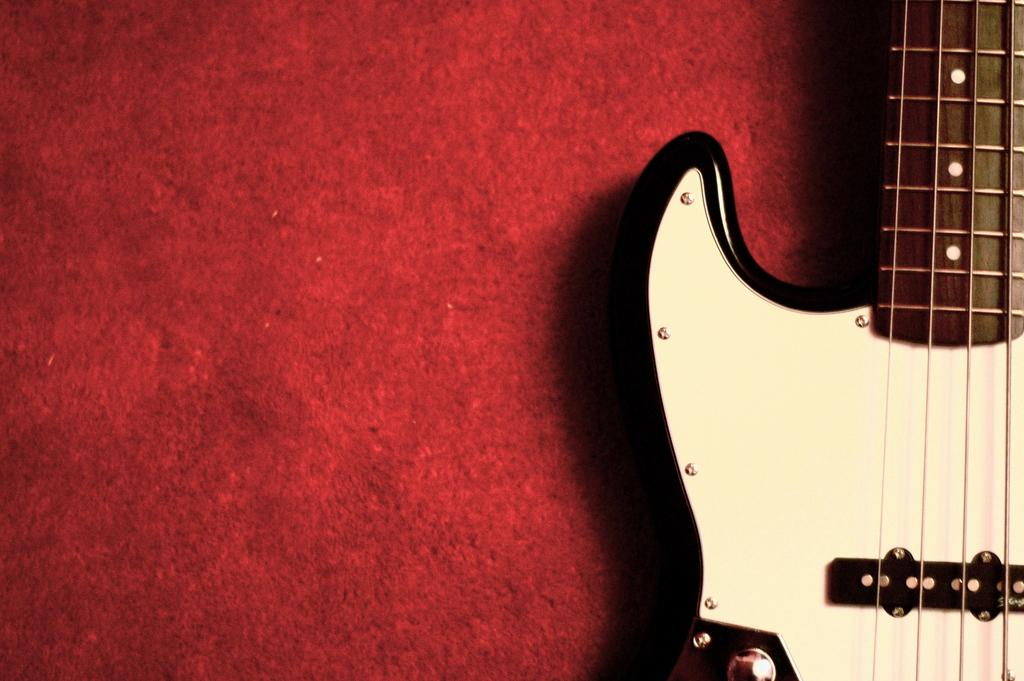What musical instrument is located on the right side of the image? There is a guitar on the right side of the image. What color can be seen in the background of the image? There is a red color visible in the background of the image. How many hours does the plantation have in the image? There is no plantation present in the image, so it is not possible to determine the number of hours. 